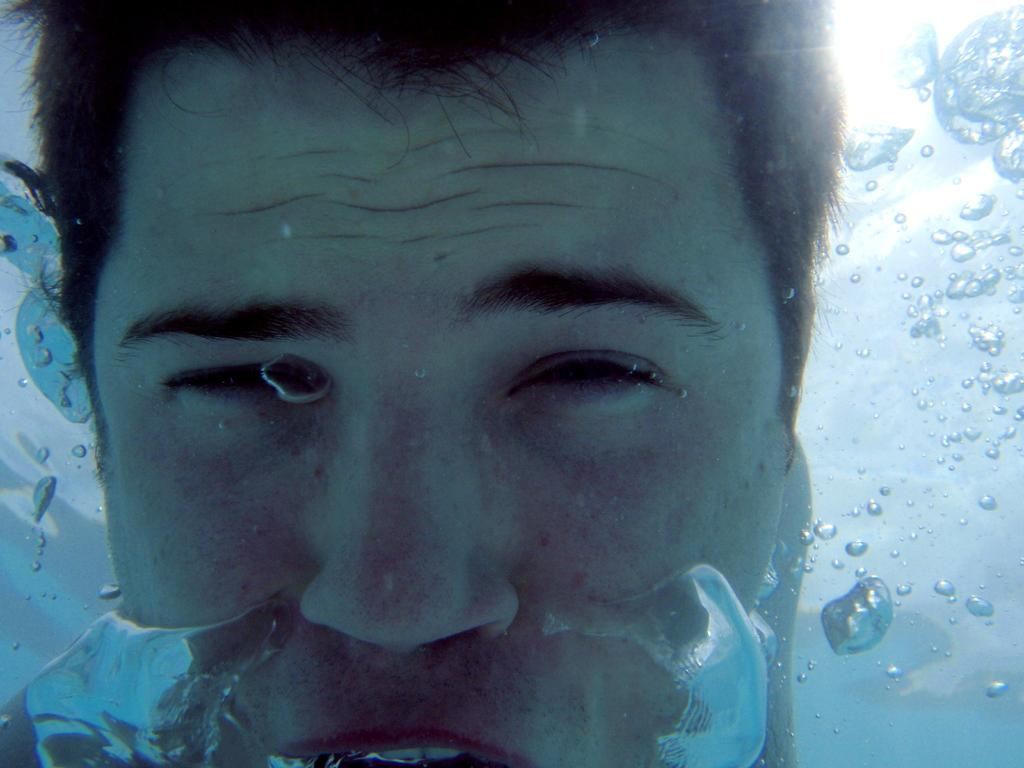Can you describe the main subject of the image? Unfortunately, there are no specific facts provided about the image, so it is impossible to describe the main subject. How many goats can be seen playing musical instruments in the image? There is no information provided about the image, so it is impossible to determine if there are any goats or musical instruments present. What type of music is being played by the snail in the image? There is no information provided about the image, so it is impossible to determine if there is a snail or any music being played. 